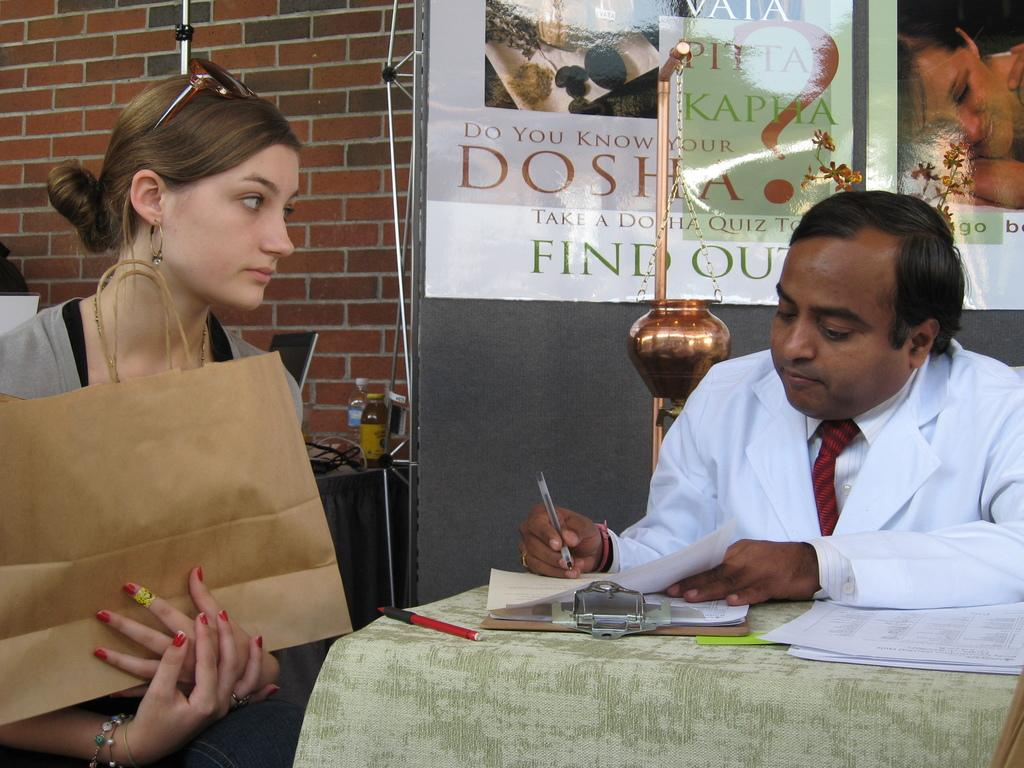How many people are sitting on the chair in the image? There are two persons sitting on a chair in the image. What can be seen on the table in the image? There is a poster and a paper on the table in the image. What is the appearance of the wall in the image? The wall has a red brick appearance. What object is present on the table that could be used for writing? There is a pen on the table in the image. What type of mark can be seen on the poster during the winter season in the image? There is no mention of a mark on the poster or any reference to winter in the image. 